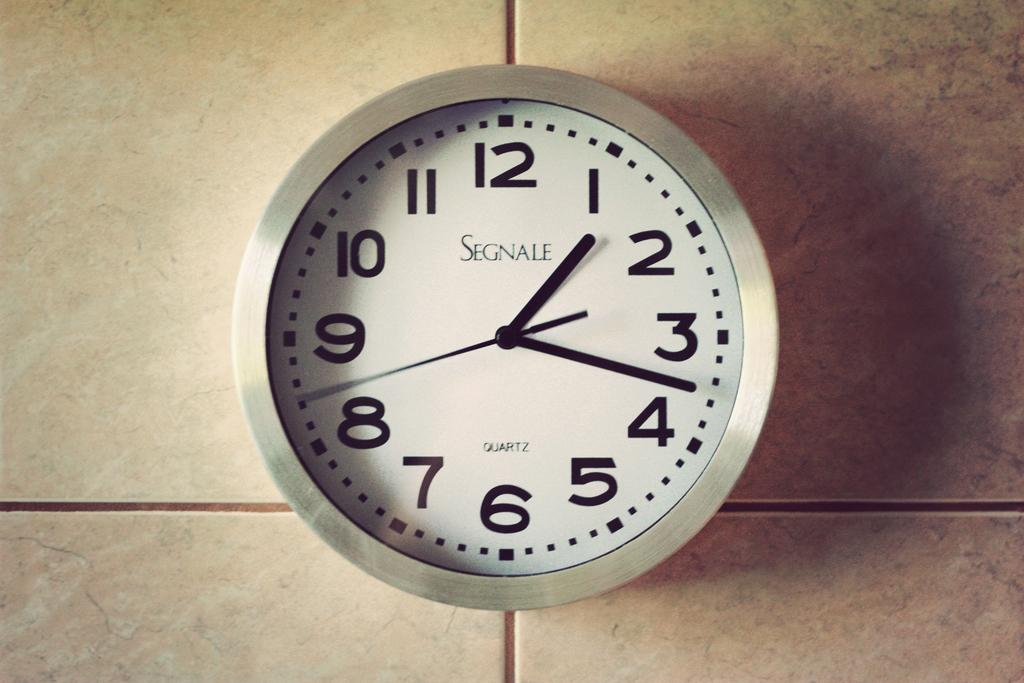<image>
Give a short and clear explanation of the subsequent image. An analog wall clock with the word SEGNALE in the center. 